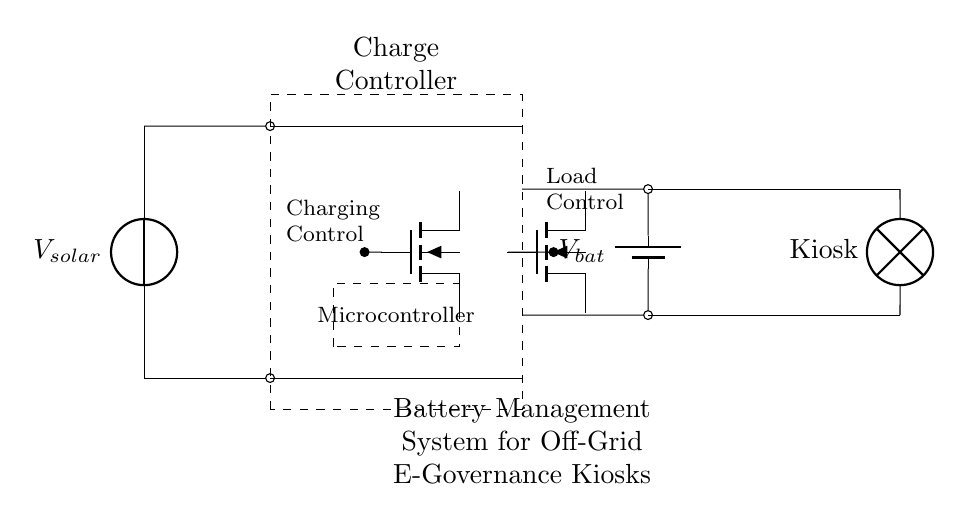What is the primary source of power in this circuit? The primary power source is the solar panel, represented by the voltage source labeled V_solar at the top of the diagram. It provides the necessary energy to the circuit.
Answer: solar panel What component is used to manage battery charging? The charge controller, indicated by the dashed rectangle, is responsible for managing the charging of the battery by regulating the flow of current from the solar panel to the battery.
Answer: charge controller How many MOSFETs are present in the circuit? There are two MOSFETs in the circuit. One is labeled for charging control, and the other is for load control, as indicated near their respective positions in the diagram.
Answer: two What is the output load of the circuit designated for? The output load is designated for the e-governance kiosk, indicated by the lamp symbol labeled 'Kiosk' at the bottom right of the circuit diagram.
Answer: Kiosk What is the voltage labeled for the battery in the circuit? The voltage labeled for the battery is V_bat, which signifies the potential stored in the battery that powers the e-governance kiosk when the solar panel is not providing energy.
Answer: V_bat Explain the relationship between the solar panel and the battery. The solar panel generates electricity (V_solar) to charge the battery (V_bat) through the charge controller. The panel's output needs to go through the controller to ensure efficient and safe charging based on the state of the battery.
Answer: charging relationship What does the Microcontroller in the circuit manage? The Microcontroller is responsible for managing the operations of the battery management system, including controlling the charging and discharging process and ensuring the safe operation of the circuit and load.
Answer: operations management 